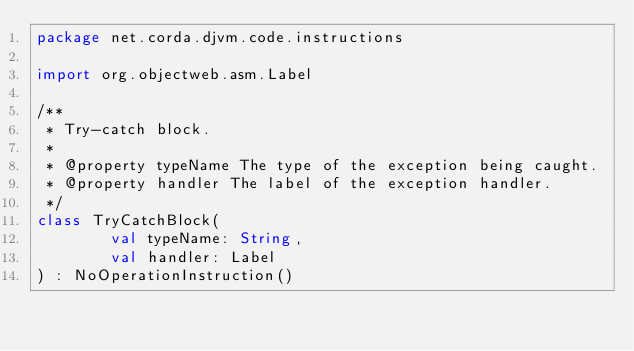Convert code to text. <code><loc_0><loc_0><loc_500><loc_500><_Kotlin_>package net.corda.djvm.code.instructions

import org.objectweb.asm.Label

/**
 * Try-catch block.
 *
 * @property typeName The type of the exception being caught.
 * @property handler The label of the exception handler.
 */
class TryCatchBlock(
        val typeName: String,
        val handler: Label
) : NoOperationInstruction()
</code> 